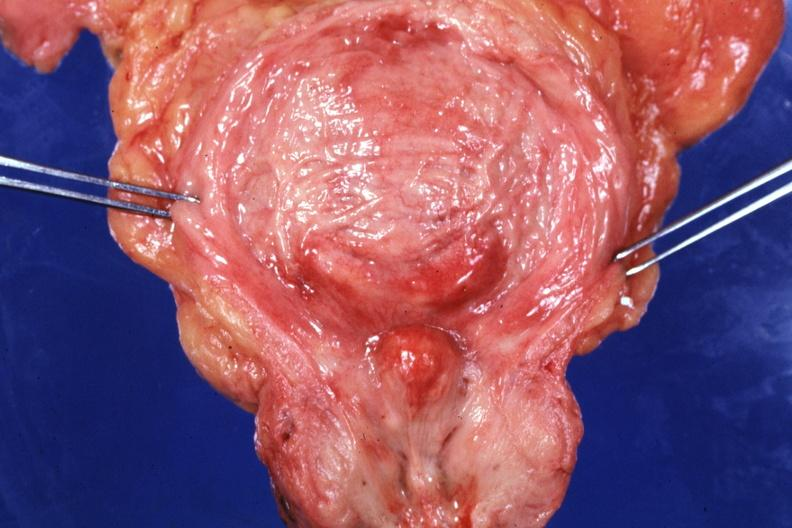s prostate present?
Answer the question using a single word or phrase. Yes 